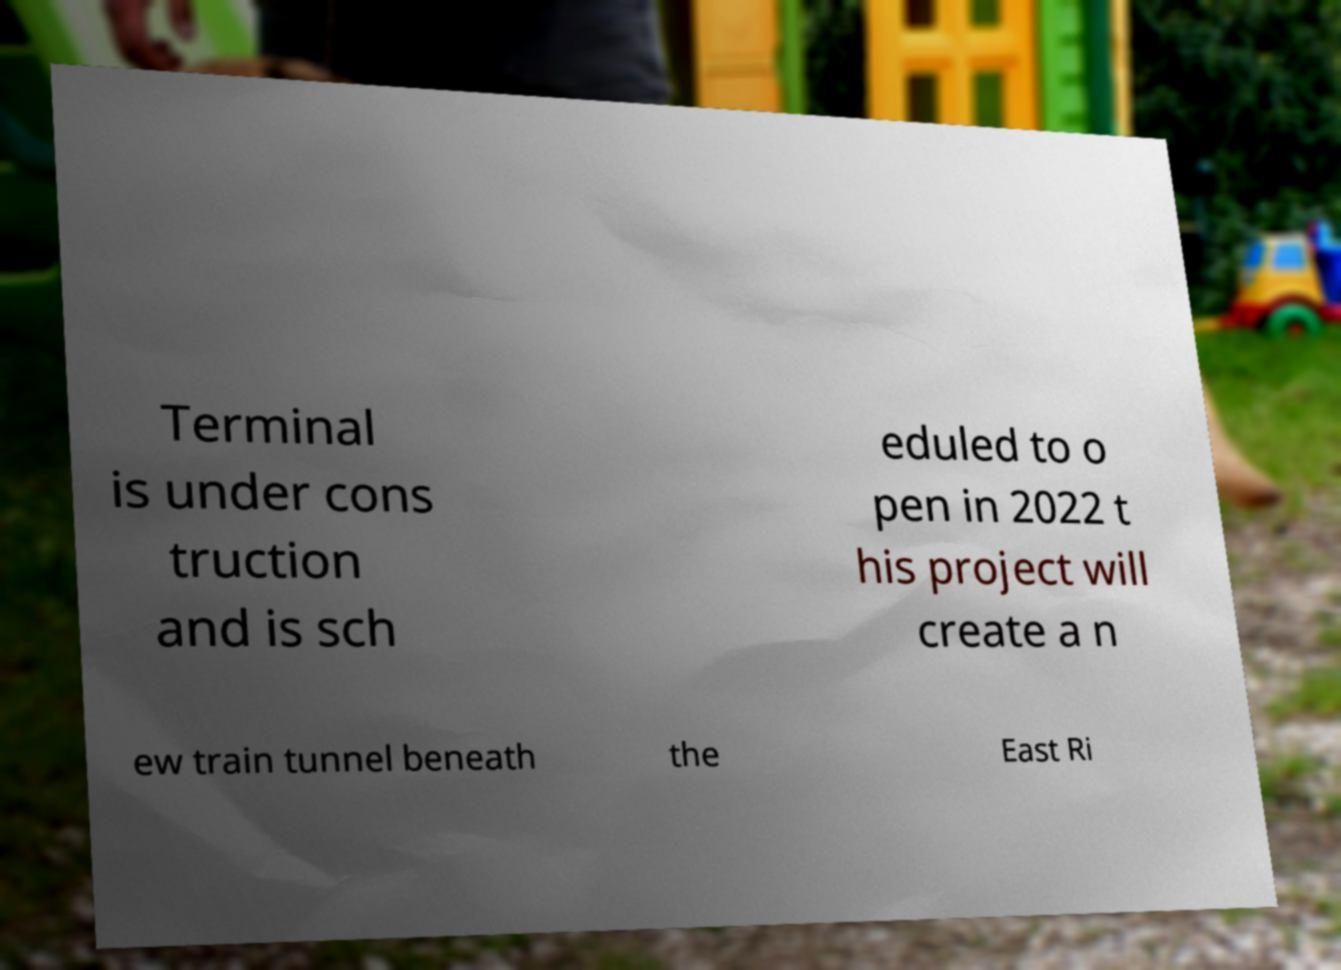Can you read and provide the text displayed in the image?This photo seems to have some interesting text. Can you extract and type it out for me? Terminal is under cons truction and is sch eduled to o pen in 2022 t his project will create a n ew train tunnel beneath the East Ri 